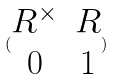Convert formula to latex. <formula><loc_0><loc_0><loc_500><loc_500>( \begin{matrix} R ^ { \times } & R \\ 0 & 1 \end{matrix} )</formula> 